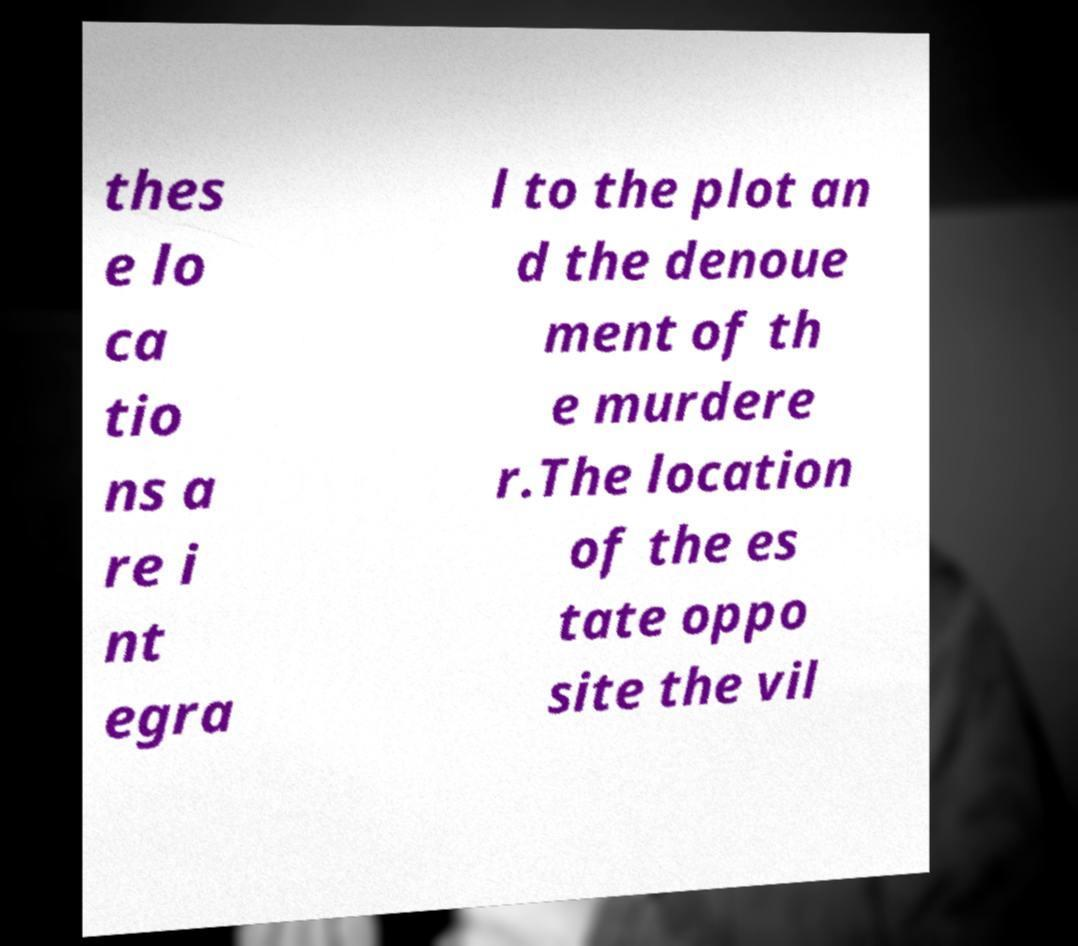What messages or text are displayed in this image? I need them in a readable, typed format. thes e lo ca tio ns a re i nt egra l to the plot an d the denoue ment of th e murdere r.The location of the es tate oppo site the vil 